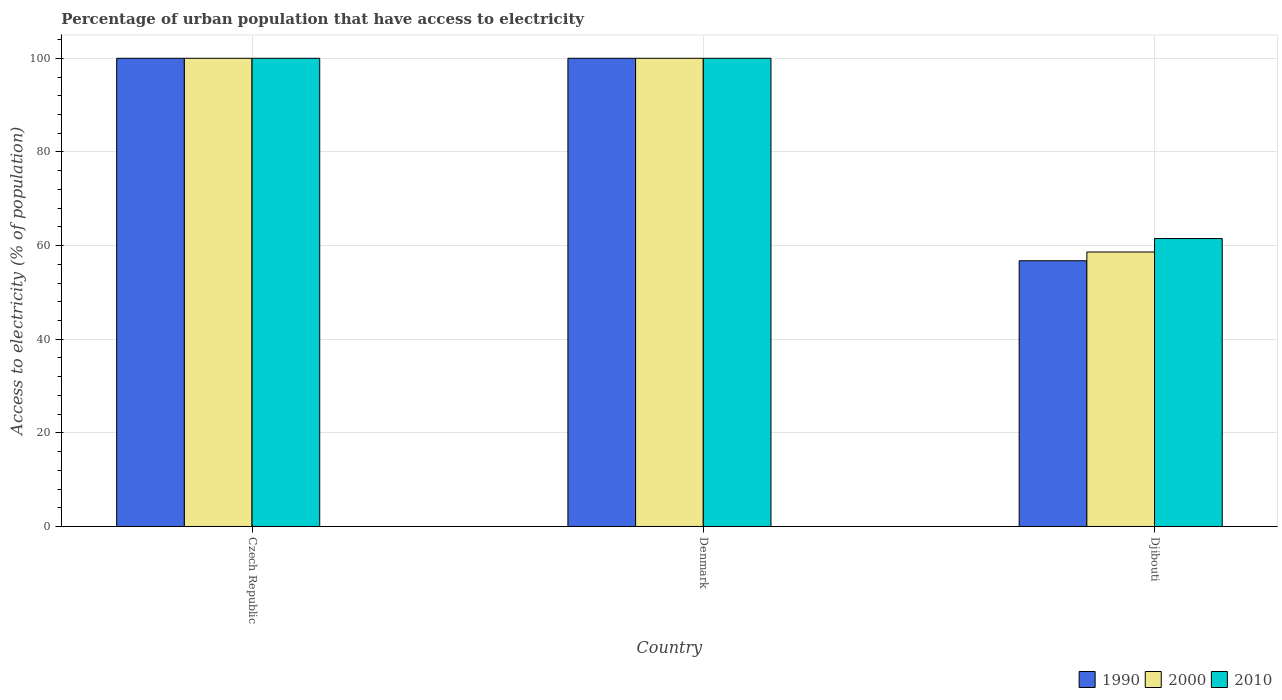How many different coloured bars are there?
Your answer should be very brief. 3. How many groups of bars are there?
Make the answer very short. 3. Are the number of bars on each tick of the X-axis equal?
Your answer should be compact. Yes. How many bars are there on the 1st tick from the right?
Provide a succinct answer. 3. What is the label of the 3rd group of bars from the left?
Make the answer very short. Djibouti. In how many cases, is the number of bars for a given country not equal to the number of legend labels?
Give a very brief answer. 0. What is the percentage of urban population that have access to electricity in 2000 in Djibouti?
Offer a terse response. 58.63. Across all countries, what is the maximum percentage of urban population that have access to electricity in 2000?
Offer a terse response. 100. Across all countries, what is the minimum percentage of urban population that have access to electricity in 1990?
Make the answer very short. 56.76. In which country was the percentage of urban population that have access to electricity in 1990 maximum?
Provide a succinct answer. Czech Republic. In which country was the percentage of urban population that have access to electricity in 2000 minimum?
Your answer should be very brief. Djibouti. What is the total percentage of urban population that have access to electricity in 1990 in the graph?
Provide a succinct answer. 256.76. What is the difference between the percentage of urban population that have access to electricity in 2010 in Denmark and the percentage of urban population that have access to electricity in 1990 in Djibouti?
Your answer should be very brief. 43.24. What is the average percentage of urban population that have access to electricity in 2010 per country?
Provide a short and direct response. 87.17. What is the difference between the percentage of urban population that have access to electricity of/in 2000 and percentage of urban population that have access to electricity of/in 1990 in Djibouti?
Your answer should be very brief. 1.87. What is the ratio of the percentage of urban population that have access to electricity in 1990 in Czech Republic to that in Denmark?
Provide a succinct answer. 1. What is the difference between the highest and the second highest percentage of urban population that have access to electricity in 2000?
Your response must be concise. -41.37. What is the difference between the highest and the lowest percentage of urban population that have access to electricity in 1990?
Your answer should be very brief. 43.24. What does the 2nd bar from the left in Denmark represents?
Provide a short and direct response. 2000. What does the 1st bar from the right in Czech Republic represents?
Your answer should be compact. 2010. Is it the case that in every country, the sum of the percentage of urban population that have access to electricity in 1990 and percentage of urban population that have access to electricity in 2000 is greater than the percentage of urban population that have access to electricity in 2010?
Keep it short and to the point. Yes. How many bars are there?
Provide a succinct answer. 9. What is the difference between two consecutive major ticks on the Y-axis?
Ensure brevity in your answer.  20. Does the graph contain grids?
Your answer should be very brief. Yes. Where does the legend appear in the graph?
Make the answer very short. Bottom right. How are the legend labels stacked?
Provide a succinct answer. Horizontal. What is the title of the graph?
Give a very brief answer. Percentage of urban population that have access to electricity. Does "1967" appear as one of the legend labels in the graph?
Make the answer very short. No. What is the label or title of the X-axis?
Ensure brevity in your answer.  Country. What is the label or title of the Y-axis?
Offer a very short reply. Access to electricity (% of population). What is the Access to electricity (% of population) of 1990 in Denmark?
Provide a short and direct response. 100. What is the Access to electricity (% of population) of 2000 in Denmark?
Offer a very short reply. 100. What is the Access to electricity (% of population) in 1990 in Djibouti?
Your answer should be very brief. 56.76. What is the Access to electricity (% of population) in 2000 in Djibouti?
Your response must be concise. 58.63. What is the Access to electricity (% of population) in 2010 in Djibouti?
Your answer should be very brief. 61.5. Across all countries, what is the minimum Access to electricity (% of population) of 1990?
Give a very brief answer. 56.76. Across all countries, what is the minimum Access to electricity (% of population) in 2000?
Keep it short and to the point. 58.63. Across all countries, what is the minimum Access to electricity (% of population) of 2010?
Ensure brevity in your answer.  61.5. What is the total Access to electricity (% of population) of 1990 in the graph?
Ensure brevity in your answer.  256.76. What is the total Access to electricity (% of population) in 2000 in the graph?
Keep it short and to the point. 258.63. What is the total Access to electricity (% of population) of 2010 in the graph?
Ensure brevity in your answer.  261.5. What is the difference between the Access to electricity (% of population) of 1990 in Czech Republic and that in Denmark?
Ensure brevity in your answer.  0. What is the difference between the Access to electricity (% of population) in 2000 in Czech Republic and that in Denmark?
Offer a terse response. 0. What is the difference between the Access to electricity (% of population) of 1990 in Czech Republic and that in Djibouti?
Your response must be concise. 43.24. What is the difference between the Access to electricity (% of population) in 2000 in Czech Republic and that in Djibouti?
Your answer should be very brief. 41.37. What is the difference between the Access to electricity (% of population) of 2010 in Czech Republic and that in Djibouti?
Offer a terse response. 38.5. What is the difference between the Access to electricity (% of population) of 1990 in Denmark and that in Djibouti?
Offer a terse response. 43.24. What is the difference between the Access to electricity (% of population) of 2000 in Denmark and that in Djibouti?
Ensure brevity in your answer.  41.37. What is the difference between the Access to electricity (% of population) of 2010 in Denmark and that in Djibouti?
Make the answer very short. 38.5. What is the difference between the Access to electricity (% of population) of 1990 in Czech Republic and the Access to electricity (% of population) of 2000 in Denmark?
Offer a very short reply. 0. What is the difference between the Access to electricity (% of population) in 1990 in Czech Republic and the Access to electricity (% of population) in 2010 in Denmark?
Offer a terse response. 0. What is the difference between the Access to electricity (% of population) in 1990 in Czech Republic and the Access to electricity (% of population) in 2000 in Djibouti?
Give a very brief answer. 41.37. What is the difference between the Access to electricity (% of population) of 1990 in Czech Republic and the Access to electricity (% of population) of 2010 in Djibouti?
Provide a succinct answer. 38.5. What is the difference between the Access to electricity (% of population) in 2000 in Czech Republic and the Access to electricity (% of population) in 2010 in Djibouti?
Your answer should be compact. 38.5. What is the difference between the Access to electricity (% of population) of 1990 in Denmark and the Access to electricity (% of population) of 2000 in Djibouti?
Offer a very short reply. 41.37. What is the difference between the Access to electricity (% of population) of 1990 in Denmark and the Access to electricity (% of population) of 2010 in Djibouti?
Ensure brevity in your answer.  38.5. What is the difference between the Access to electricity (% of population) in 2000 in Denmark and the Access to electricity (% of population) in 2010 in Djibouti?
Keep it short and to the point. 38.5. What is the average Access to electricity (% of population) in 1990 per country?
Offer a very short reply. 85.59. What is the average Access to electricity (% of population) in 2000 per country?
Your response must be concise. 86.21. What is the average Access to electricity (% of population) of 2010 per country?
Ensure brevity in your answer.  87.17. What is the difference between the Access to electricity (% of population) in 1990 and Access to electricity (% of population) in 2010 in Denmark?
Give a very brief answer. 0. What is the difference between the Access to electricity (% of population) of 2000 and Access to electricity (% of population) of 2010 in Denmark?
Your answer should be very brief. 0. What is the difference between the Access to electricity (% of population) in 1990 and Access to electricity (% of population) in 2000 in Djibouti?
Ensure brevity in your answer.  -1.87. What is the difference between the Access to electricity (% of population) of 1990 and Access to electricity (% of population) of 2010 in Djibouti?
Make the answer very short. -4.74. What is the difference between the Access to electricity (% of population) in 2000 and Access to electricity (% of population) in 2010 in Djibouti?
Your answer should be very brief. -2.87. What is the ratio of the Access to electricity (% of population) in 2000 in Czech Republic to that in Denmark?
Give a very brief answer. 1. What is the ratio of the Access to electricity (% of population) in 2010 in Czech Republic to that in Denmark?
Your response must be concise. 1. What is the ratio of the Access to electricity (% of population) in 1990 in Czech Republic to that in Djibouti?
Provide a short and direct response. 1.76. What is the ratio of the Access to electricity (% of population) in 2000 in Czech Republic to that in Djibouti?
Provide a short and direct response. 1.71. What is the ratio of the Access to electricity (% of population) of 2010 in Czech Republic to that in Djibouti?
Ensure brevity in your answer.  1.63. What is the ratio of the Access to electricity (% of population) of 1990 in Denmark to that in Djibouti?
Offer a terse response. 1.76. What is the ratio of the Access to electricity (% of population) in 2000 in Denmark to that in Djibouti?
Provide a short and direct response. 1.71. What is the ratio of the Access to electricity (% of population) of 2010 in Denmark to that in Djibouti?
Your answer should be very brief. 1.63. What is the difference between the highest and the second highest Access to electricity (% of population) of 1990?
Offer a terse response. 0. What is the difference between the highest and the second highest Access to electricity (% of population) in 2000?
Your answer should be very brief. 0. What is the difference between the highest and the second highest Access to electricity (% of population) in 2010?
Your answer should be very brief. 0. What is the difference between the highest and the lowest Access to electricity (% of population) in 1990?
Your response must be concise. 43.24. What is the difference between the highest and the lowest Access to electricity (% of population) in 2000?
Keep it short and to the point. 41.37. What is the difference between the highest and the lowest Access to electricity (% of population) in 2010?
Your response must be concise. 38.5. 